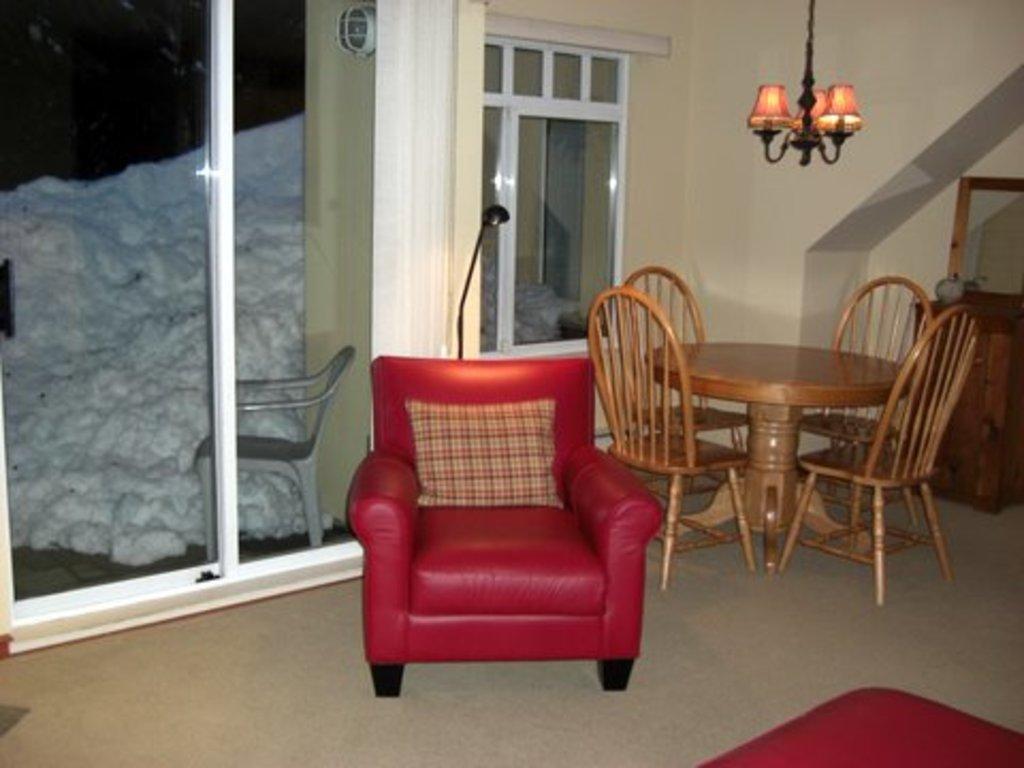Please provide a concise description of this image. In this image we can see an inner view of a living room containing a sofa with a cushion and a dining table with some chairs. We can also see some windows, chairs, ceiling lights, cupboard and the floor. 